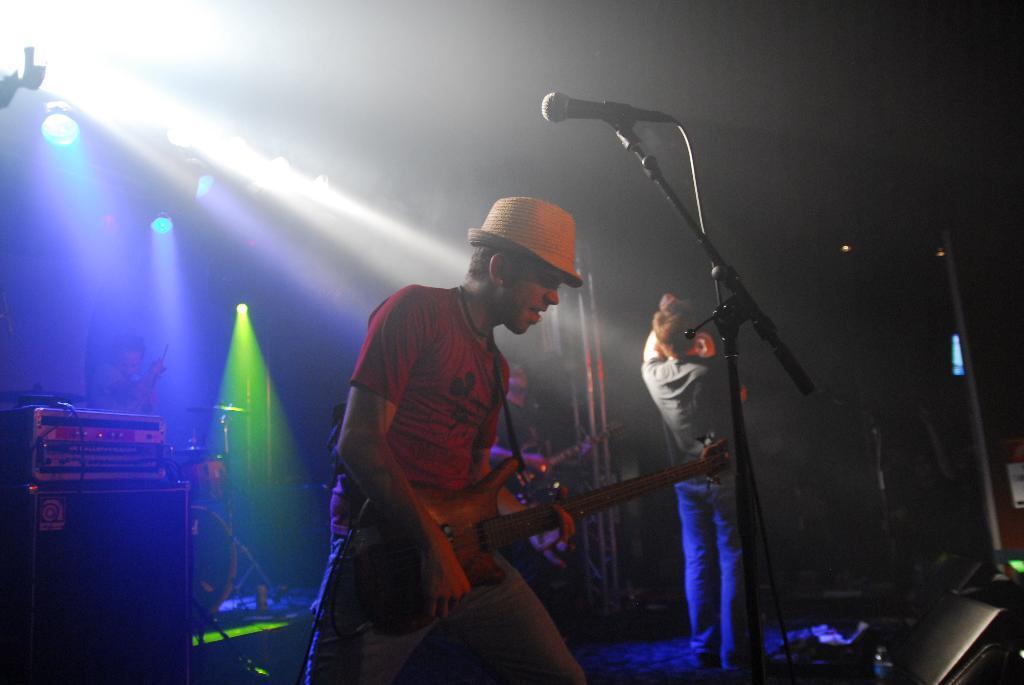Could you give a brief overview of what you see in this image? In the center of the image we can see a man standing and playing a guitar, before him there is a mic placed on the stand, next to him there is another man. On the right there is a speaker. In the background there are lights. 